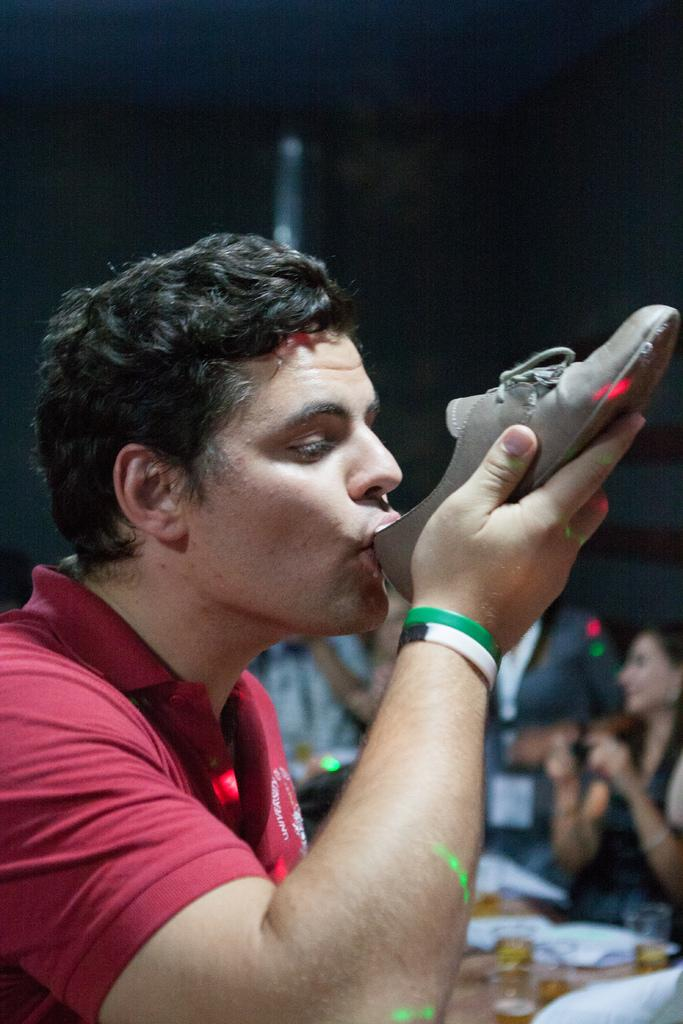What is the man in the image holding? The man is holding a shoe. What is the shoe doing in relation to the man's mouth? The shoe is touching the man's mouth. Are there any other people present in the image? Yes, there are other people in the image. Can you see a ring floating on the sea in the image? There is no sea or ring present in the image. 